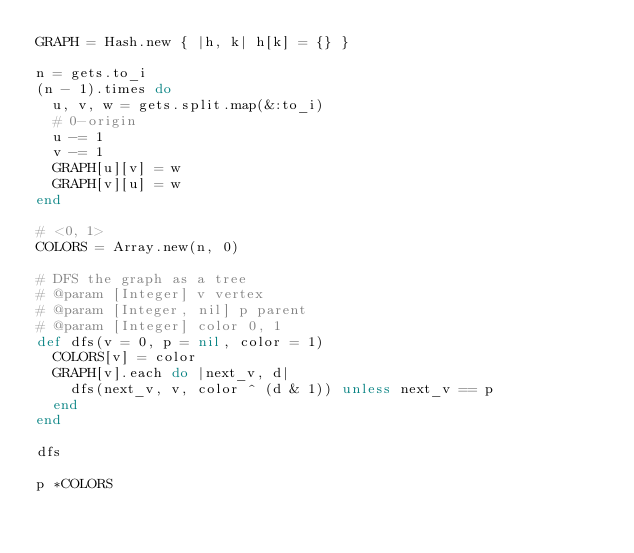Convert code to text. <code><loc_0><loc_0><loc_500><loc_500><_Ruby_>GRAPH = Hash.new { |h, k| h[k] = {} }

n = gets.to_i
(n - 1).times do
  u, v, w = gets.split.map(&:to_i)
  # 0-origin
  u -= 1
  v -= 1
  GRAPH[u][v] = w
  GRAPH[v][u] = w
end

# <0, 1>
COLORS = Array.new(n, 0)

# DFS the graph as a tree
# @param [Integer] v vertex
# @param [Integer, nil] p parent
# @param [Integer] color 0, 1
def dfs(v = 0, p = nil, color = 1)
  COLORS[v] = color
  GRAPH[v].each do |next_v, d|
    dfs(next_v, v, color ^ (d & 1)) unless next_v == p
  end
end

dfs

p *COLORS
</code> 